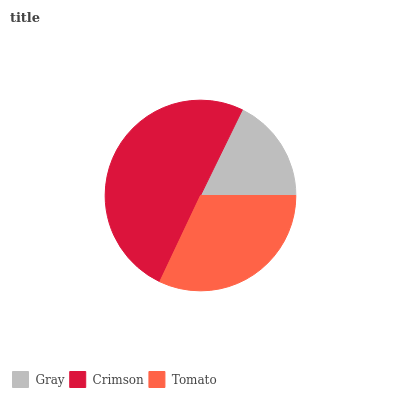Is Gray the minimum?
Answer yes or no. Yes. Is Crimson the maximum?
Answer yes or no. Yes. Is Tomato the minimum?
Answer yes or no. No. Is Tomato the maximum?
Answer yes or no. No. Is Crimson greater than Tomato?
Answer yes or no. Yes. Is Tomato less than Crimson?
Answer yes or no. Yes. Is Tomato greater than Crimson?
Answer yes or no. No. Is Crimson less than Tomato?
Answer yes or no. No. Is Tomato the high median?
Answer yes or no. Yes. Is Tomato the low median?
Answer yes or no. Yes. Is Crimson the high median?
Answer yes or no. No. Is Gray the low median?
Answer yes or no. No. 